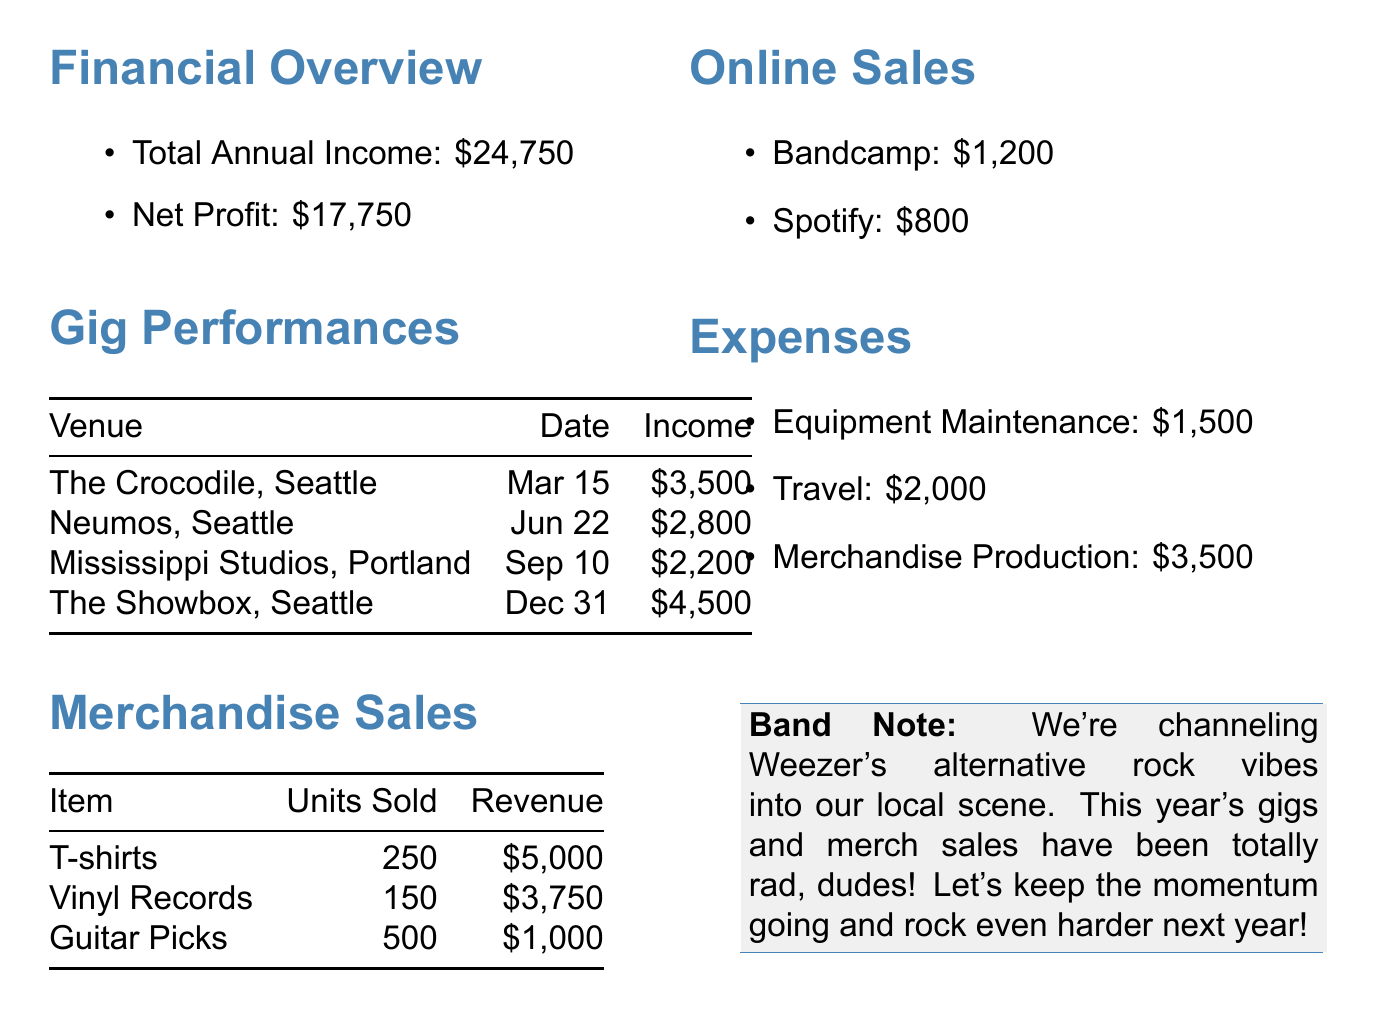What was the total annual income? The total annual income is provided under the financial overview section of the document.
Answer: 24750 How much did the band earn from The Showbox? The income from The Showbox is listed in the gig performances section.
Answer: 4500 How many units of T-shirts were sold? The number of T-shirts sold is included in the merchandise sales table.
Answer: 250 What were the total expenses? The total expenses can be inferred from the expenses section, which lists individual expenses.
Answer: 7000 What was the net profit for the year? The net profit is explicitly mentioned in the financial overview section.
Answer: 17750 Which venue in Seattle generated the most income? The venue with the highest income can be identified from the gig performances table.
Answer: The Showbox, Seattle How much revenue was generated from merchandise sales? Total revenue from merchandise can be calculated by summing the revenues for all listed merchandise items.
Answer: 8750 How much did the band earn from Bandcamp? The income from Bandcamp is specified in the online sales section of the document.
Answer: 1200 What was the date of the performance at Neumos? The date for the Neumos performance is recorded under the gig performances section.
Answer: June 22 